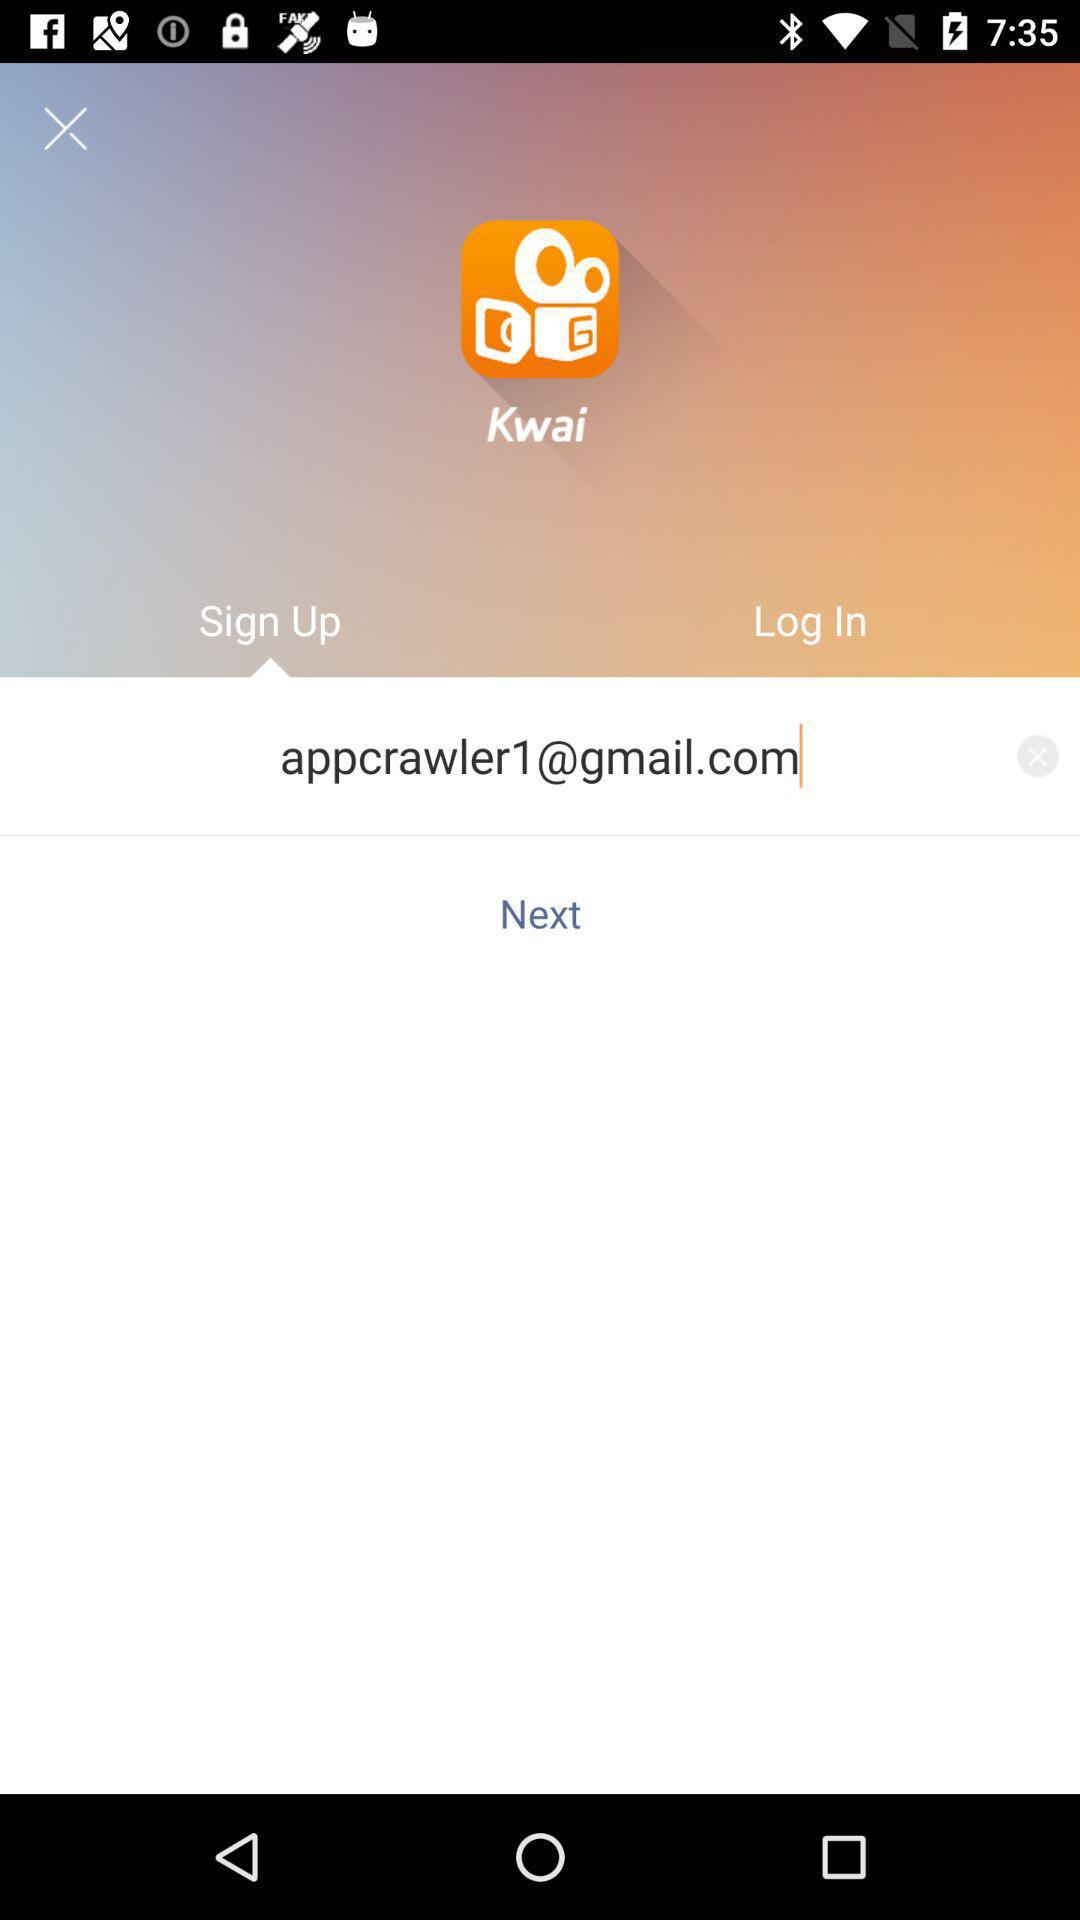What is the name of the application? The name of the application is "Kwai". 